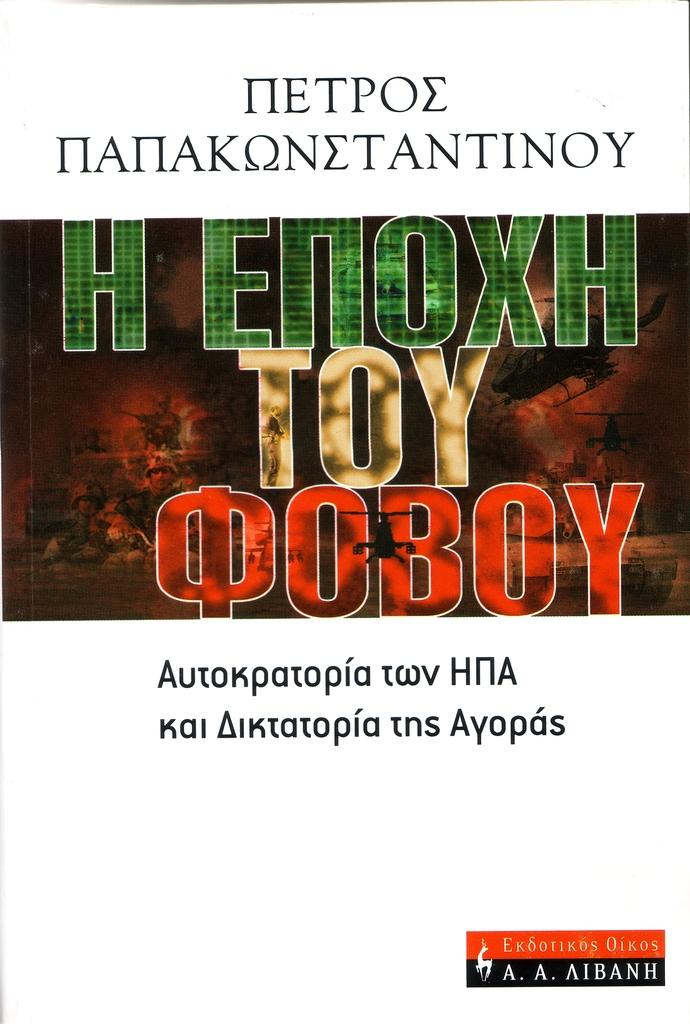What is present in the image that has writing on it? There is a paper in the image that has writing on it. What colors are used for the writing on the paper? The writing on the paper is in black, green, and red colors. What type of locket can be seen hanging from the paper in the image? There is no locket present in the image; it only features a paper with writing on it. What type of quill is used for writing on the paper in the image? There is no quill visible in the image, and the writing on the paper is not specified to be done with a quill. 